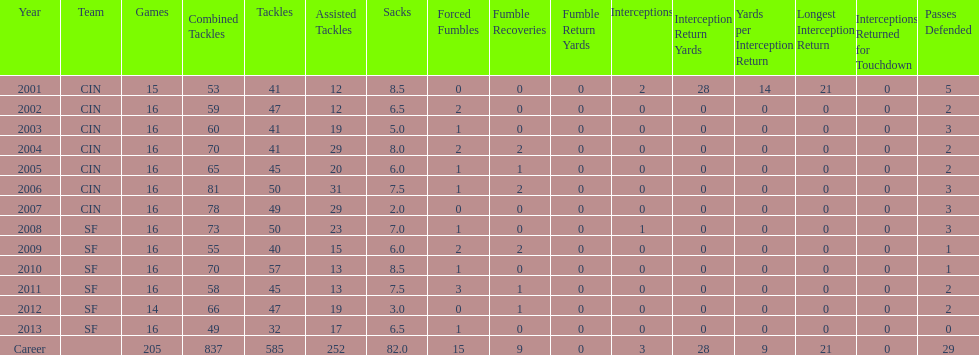In how many continuous seasons has he participated in sixteen games? 10. Could you parse the entire table as a dict? {'header': ['Year', 'Team', 'Games', 'Combined Tackles', 'Tackles', 'Assisted Tackles', 'Sacks', 'Forced Fumbles', 'Fumble Recoveries', 'Fumble Return Yards', 'Interceptions', 'Interception Return Yards', 'Yards per Interception Return', 'Longest Interception Return', 'Interceptions Returned for Touchdown', 'Passes Defended'], 'rows': [['2001', 'CIN', '15', '53', '41', '12', '8.5', '0', '0', '0', '2', '28', '14', '21', '0', '5'], ['2002', 'CIN', '16', '59', '47', '12', '6.5', '2', '0', '0', '0', '0', '0', '0', '0', '2'], ['2003', 'CIN', '16', '60', '41', '19', '5.0', '1', '0', '0', '0', '0', '0', '0', '0', '3'], ['2004', 'CIN', '16', '70', '41', '29', '8.0', '2', '2', '0', '0', '0', '0', '0', '0', '2'], ['2005', 'CIN', '16', '65', '45', '20', '6.0', '1', '1', '0', '0', '0', '0', '0', '0', '2'], ['2006', 'CIN', '16', '81', '50', '31', '7.5', '1', '2', '0', '0', '0', '0', '0', '0', '3'], ['2007', 'CIN', '16', '78', '49', '29', '2.0', '0', '0', '0', '0', '0', '0', '0', '0', '3'], ['2008', 'SF', '16', '73', '50', '23', '7.0', '1', '0', '0', '1', '0', '0', '0', '0', '3'], ['2009', 'SF', '16', '55', '40', '15', '6.0', '2', '2', '0', '0', '0', '0', '0', '0', '1'], ['2010', 'SF', '16', '70', '57', '13', '8.5', '1', '0', '0', '0', '0', '0', '0', '0', '1'], ['2011', 'SF', '16', '58', '45', '13', '7.5', '3', '1', '0', '0', '0', '0', '0', '0', '2'], ['2012', 'SF', '14', '66', '47', '19', '3.0', '0', '1', '0', '0', '0', '0', '0', '0', '2'], ['2013', 'SF', '16', '49', '32', '17', '6.5', '1', '0', '0', '0', '0', '0', '0', '0', '0'], ['Career', '', '205', '837', '585', '252', '82.0', '15', '9', '0', '3', '28', '9', '21', '0', '29']]} 